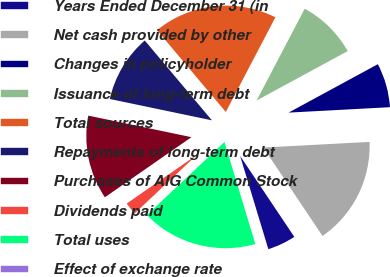Convert chart to OTSL. <chart><loc_0><loc_0><loc_500><loc_500><pie_chart><fcel>Years Ended December 31 (in<fcel>Net cash provided by other<fcel>Changes in policyholder<fcel>Issuance of long-term debt<fcel>Total sources<fcel>Repayments of long-term debt<fcel>Purchases of AIG Common Stock<fcel>Dividends paid<fcel>Total uses<fcel>Effect of exchange rate<nl><fcel>4.71%<fcel>16.46%<fcel>7.06%<fcel>9.41%<fcel>18.81%<fcel>10.59%<fcel>12.94%<fcel>2.37%<fcel>17.63%<fcel>0.02%<nl></chart> 